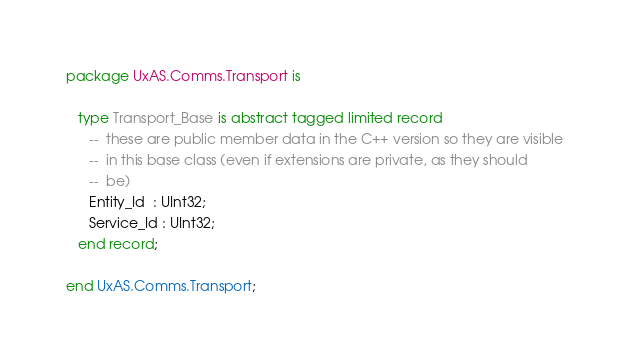<code> <loc_0><loc_0><loc_500><loc_500><_Ada_>package UxAS.Comms.Transport is

   type Transport_Base is abstract tagged limited record
      --  these are public member data in the C++ version so they are visible
      --  in this base class (even if extensions are private, as they should
      --  be)
      Entity_Id  : UInt32;
      Service_Id : UInt32;
   end record;

end UxAS.Comms.Transport;
</code> 